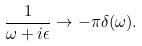<formula> <loc_0><loc_0><loc_500><loc_500>\frac { 1 } { \omega + i \epsilon } \to - \pi \delta ( \omega ) .</formula> 